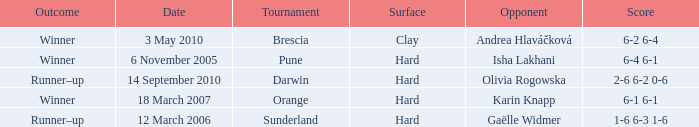When was the tournament at Orange? 18 March 2007. 